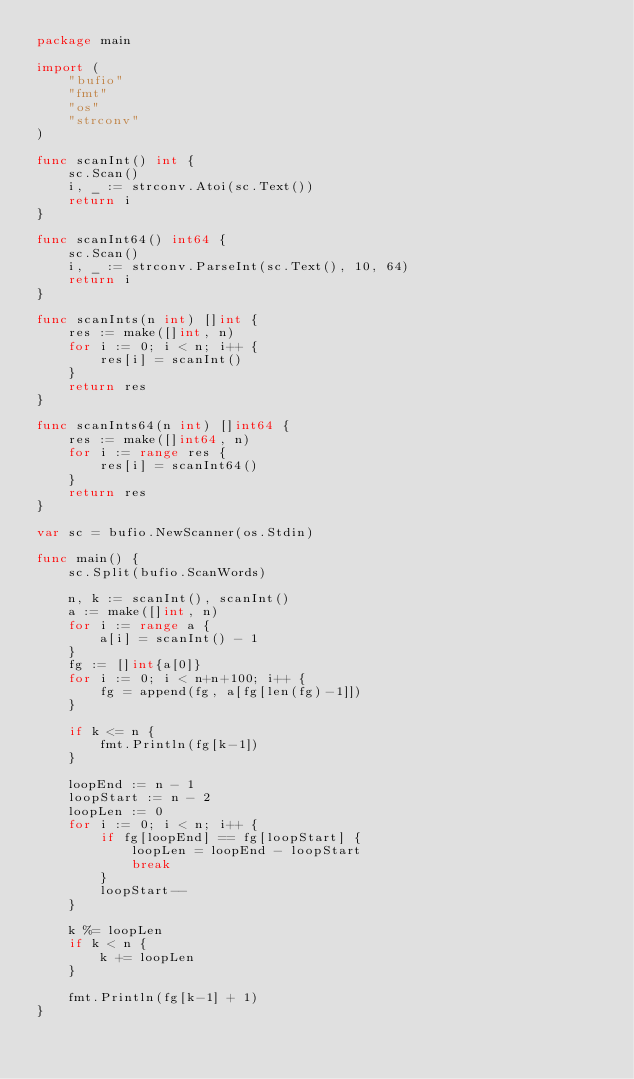Convert code to text. <code><loc_0><loc_0><loc_500><loc_500><_Go_>package main

import (
	"bufio"
	"fmt"
	"os"
	"strconv"
)

func scanInt() int {
	sc.Scan()
	i, _ := strconv.Atoi(sc.Text())
	return i
}

func scanInt64() int64 {
	sc.Scan()
	i, _ := strconv.ParseInt(sc.Text(), 10, 64)
	return i
}

func scanInts(n int) []int {
	res := make([]int, n)
	for i := 0; i < n; i++ {
		res[i] = scanInt()
	}
	return res
}

func scanInts64(n int) []int64 {
	res := make([]int64, n)
	for i := range res {
		res[i] = scanInt64()
	}
	return res
}

var sc = bufio.NewScanner(os.Stdin)

func main() {
	sc.Split(bufio.ScanWords)

	n, k := scanInt(), scanInt()
	a := make([]int, n)
	for i := range a {
		a[i] = scanInt() - 1
	}
	fg := []int{a[0]}
	for i := 0; i < n+n+100; i++ {
		fg = append(fg, a[fg[len(fg)-1]])
	}

	if k <= n {
		fmt.Println(fg[k-1])
	}

	loopEnd := n - 1
	loopStart := n - 2
	loopLen := 0
	for i := 0; i < n; i++ {
		if fg[loopEnd] == fg[loopStart] {
			loopLen = loopEnd - loopStart
			break
		}
		loopStart--
	}

	k %= loopLen
	if k < n {
		k += loopLen
	}

	fmt.Println(fg[k-1] + 1)
}
</code> 